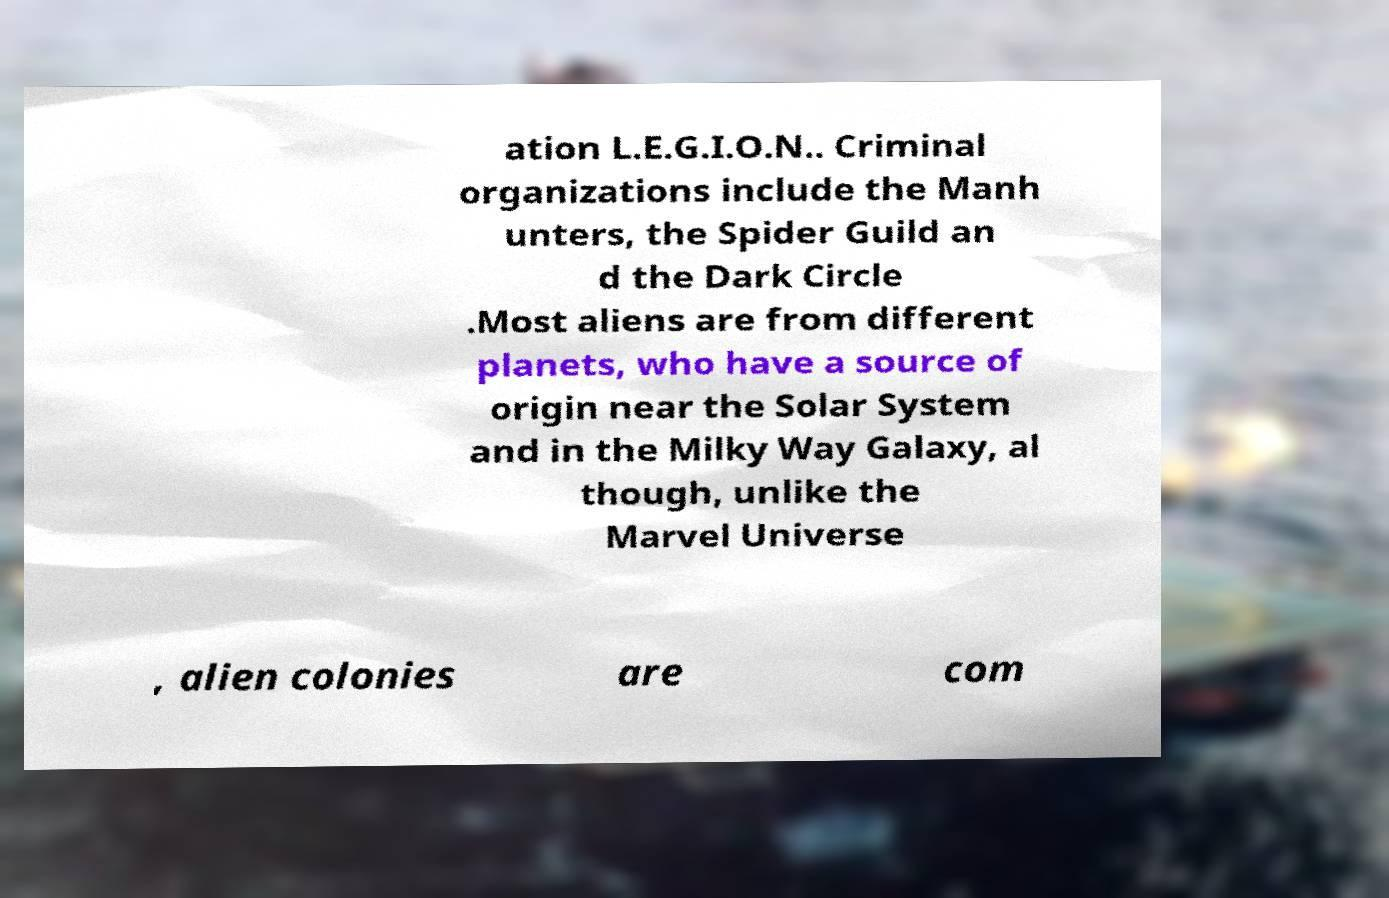Could you assist in decoding the text presented in this image and type it out clearly? ation L.E.G.I.O.N.. Criminal organizations include the Manh unters, the Spider Guild an d the Dark Circle .Most aliens are from different planets, who have a source of origin near the Solar System and in the Milky Way Galaxy, al though, unlike the Marvel Universe , alien colonies are com 